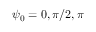Convert formula to latex. <formula><loc_0><loc_0><loc_500><loc_500>\psi _ { 0 } = 0 , \pi / 2 , \pi</formula> 